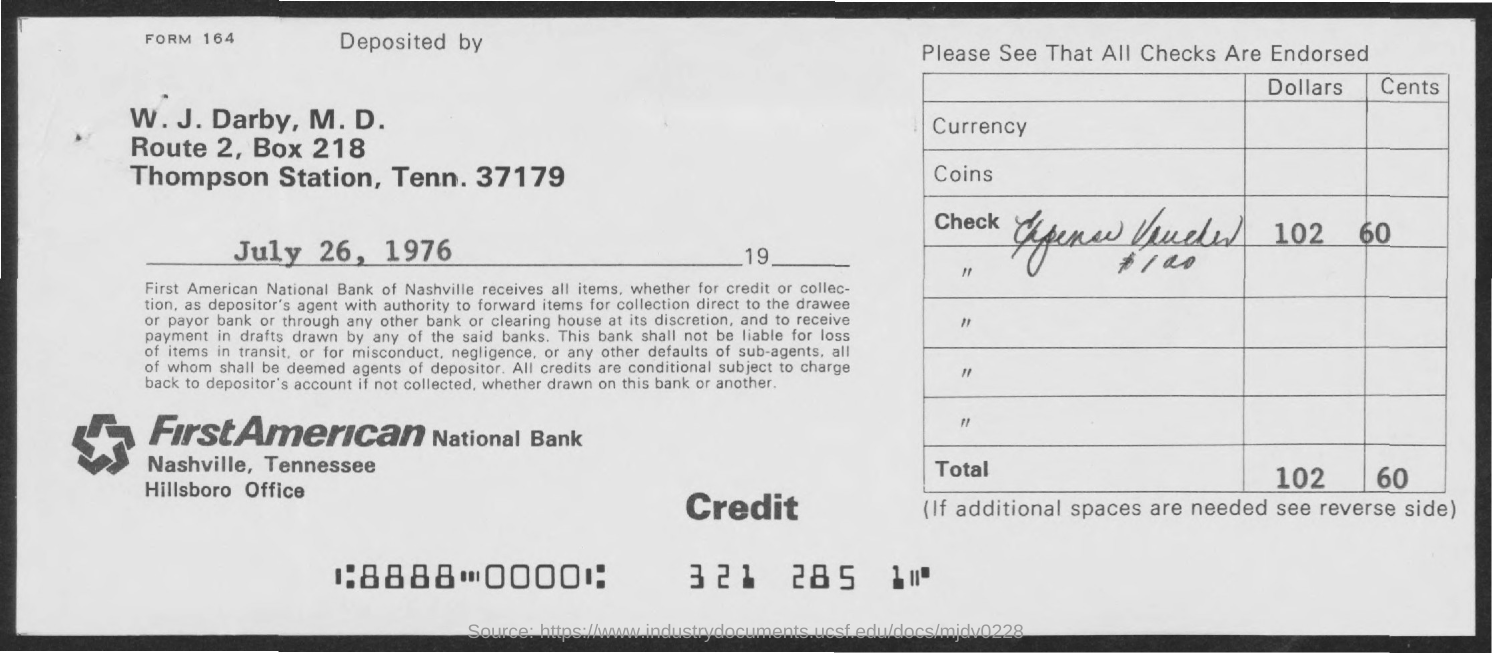List a handful of essential elements in this visual. The total amount is 102 and 60 making a total of 162. The date of deposit is July 26, 1976. What is the form number? 